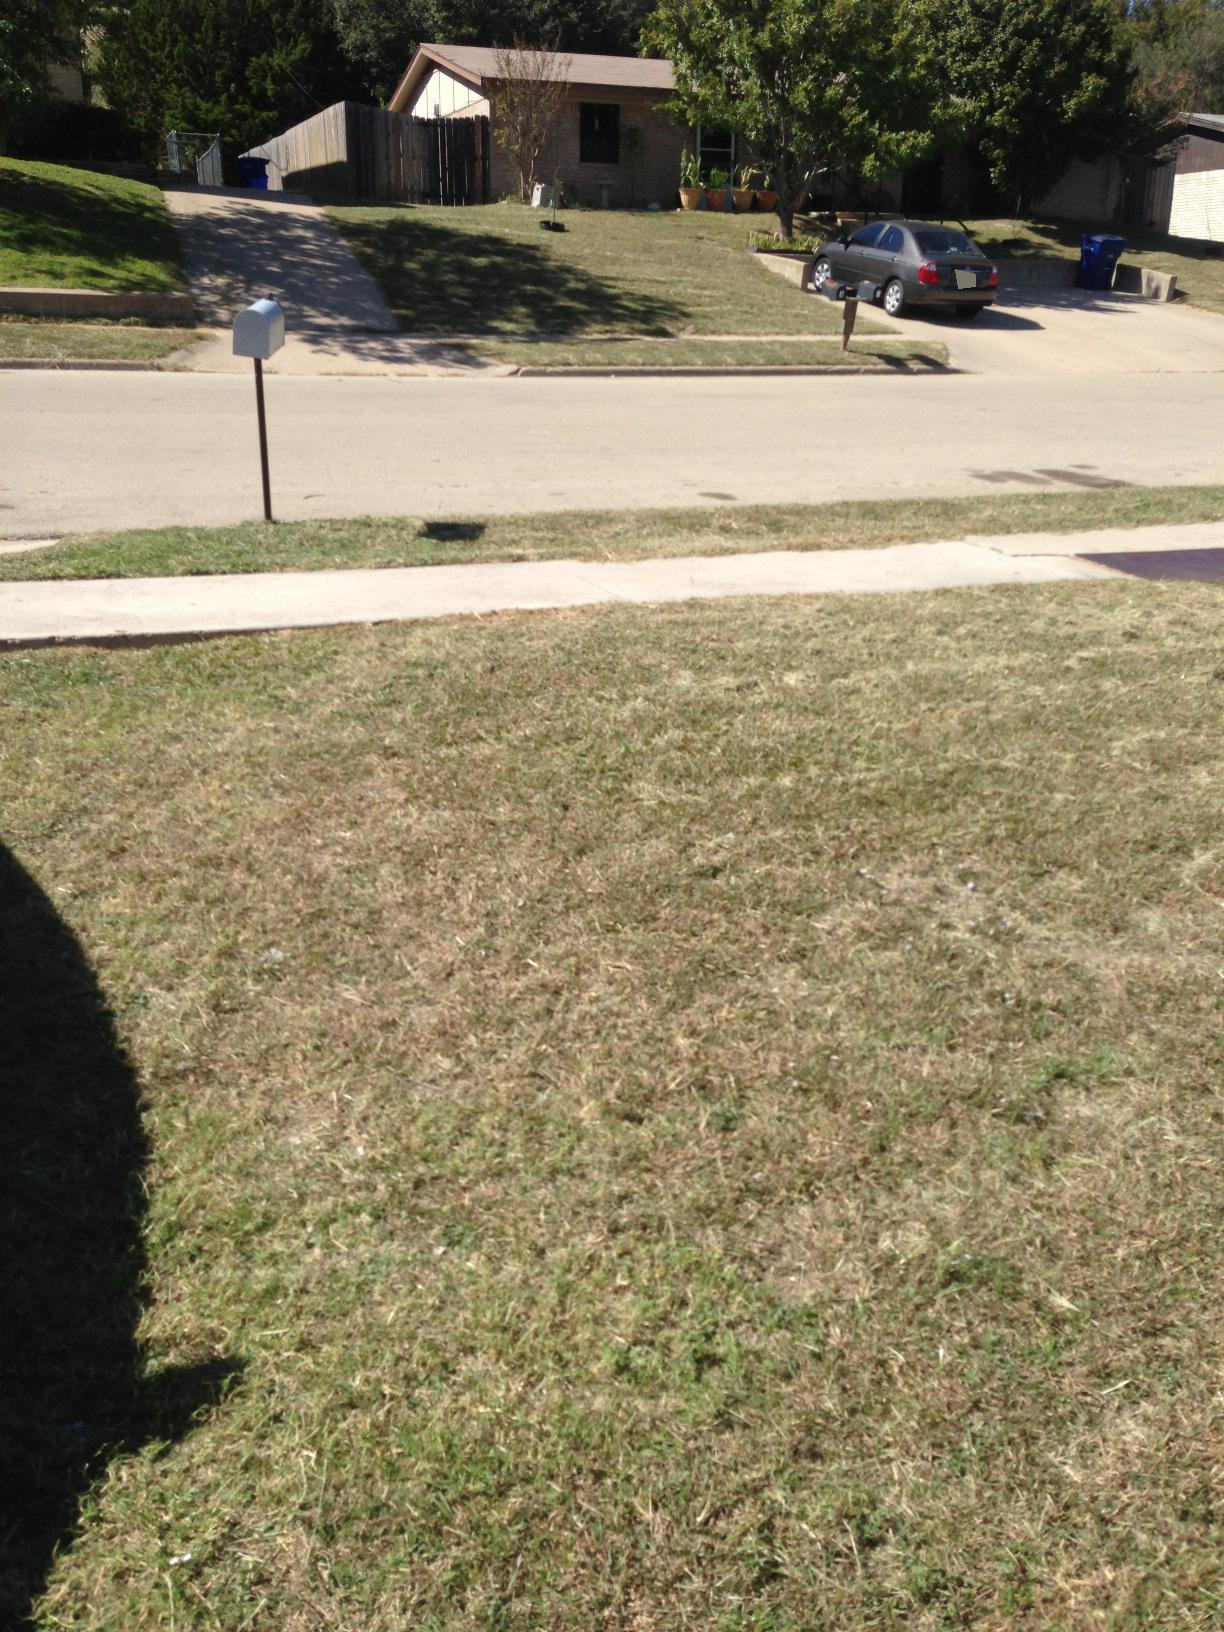Imagine a magical event happening in this setting. What would it be? Imagine waking up one morning to find that the street, usually quiet and ordinary, is now glittering with a magical golden dust. The mailbox has transformed into a whimsical talking owl delivering messages from a faraway enchanted land. The trees have become guardians of the bridge between worlds, with their leaves vibrating in harmonies that tell fantastical stories. The car parked in the driveway sprouts wings and starts to float gently, ready to take its owners on a journey to the clouds. 